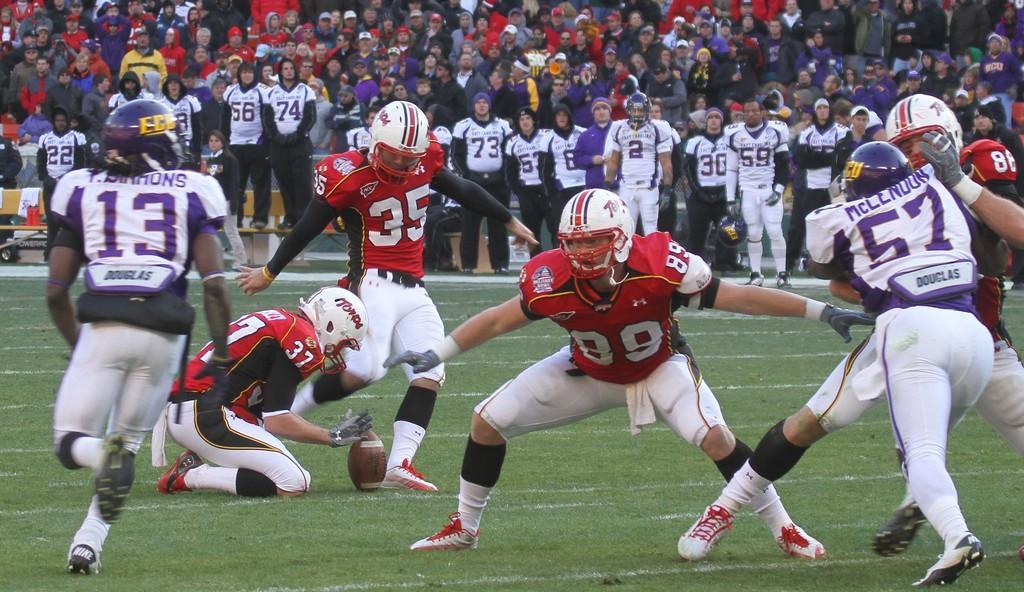In one or two sentences, can you explain what this image depicts? In this image there are players playing on a ground, in the background there are people standing and few are sitting on chairs. 